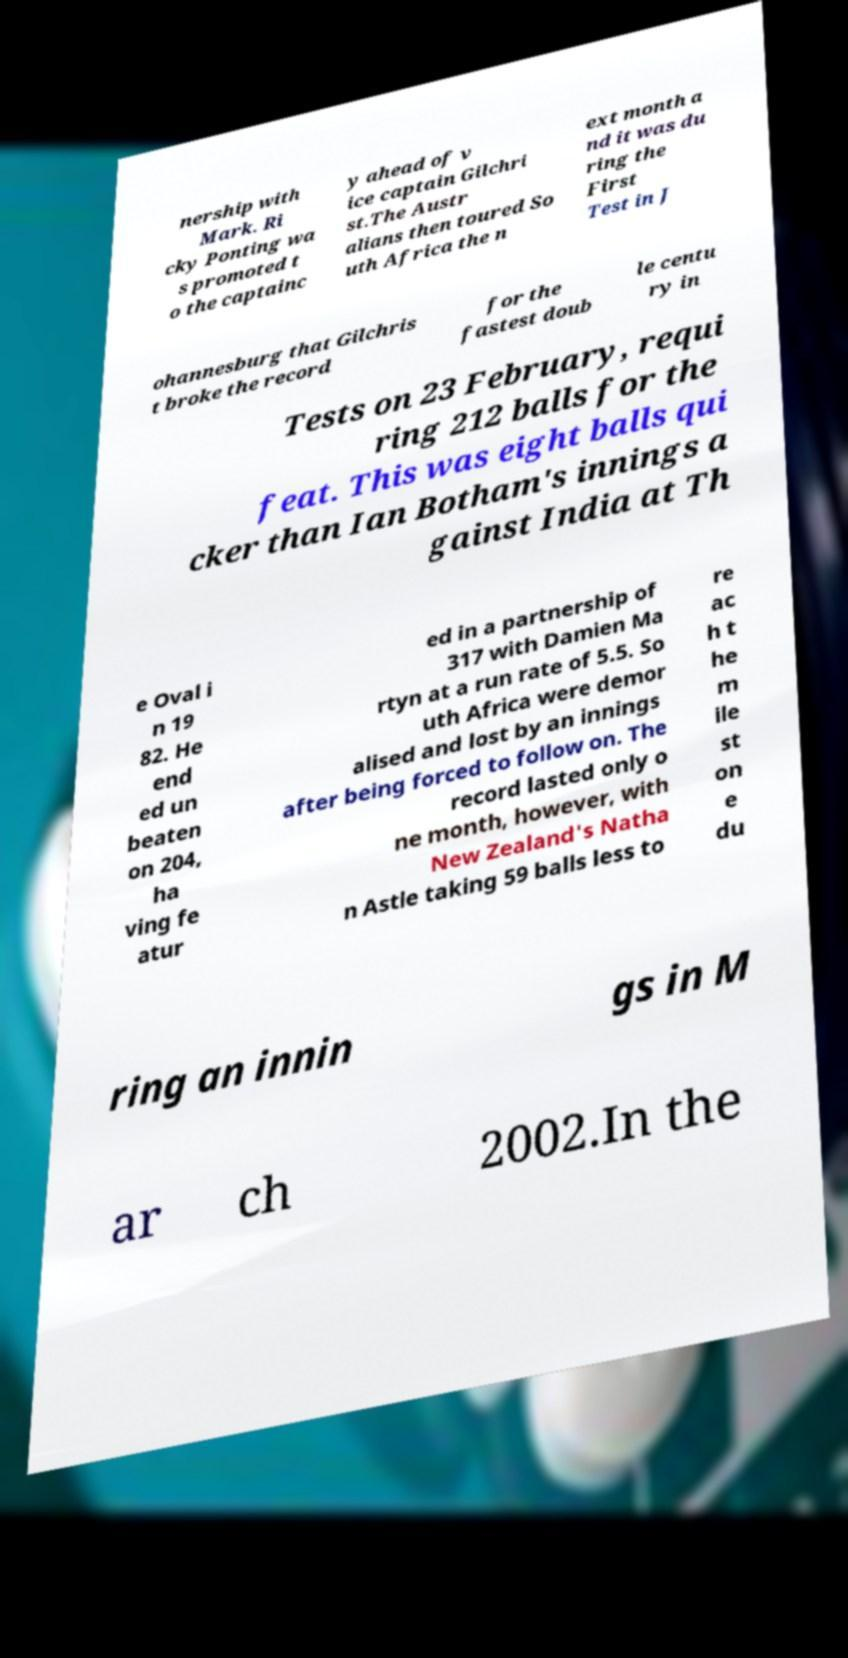Could you assist in decoding the text presented in this image and type it out clearly? nership with Mark. Ri cky Ponting wa s promoted t o the captainc y ahead of v ice captain Gilchri st.The Austr alians then toured So uth Africa the n ext month a nd it was du ring the First Test in J ohannesburg that Gilchris t broke the record for the fastest doub le centu ry in Tests on 23 February, requi ring 212 balls for the feat. This was eight balls qui cker than Ian Botham's innings a gainst India at Th e Oval i n 19 82. He end ed un beaten on 204, ha ving fe atur ed in a partnership of 317 with Damien Ma rtyn at a run rate of 5.5. So uth Africa were demor alised and lost by an innings after being forced to follow on. The record lasted only o ne month, however, with New Zealand's Natha n Astle taking 59 balls less to re ac h t he m ile st on e du ring an innin gs in M ar ch 2002.In the 